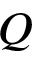Convert formula to latex. <formula><loc_0><loc_0><loc_500><loc_500>Q</formula> 